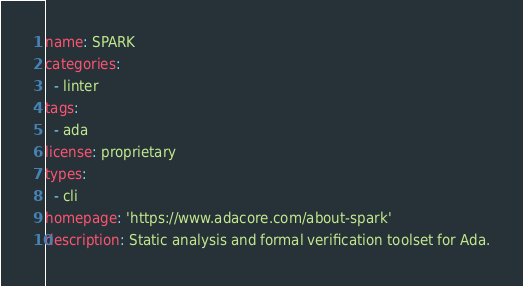Convert code to text. <code><loc_0><loc_0><loc_500><loc_500><_YAML_>name: SPARK
categories:
  - linter
tags:
  - ada
license: proprietary
types:
  - cli
homepage: 'https://www.adacore.com/about-spark'
description: Static analysis and formal verification toolset for Ada.
</code> 